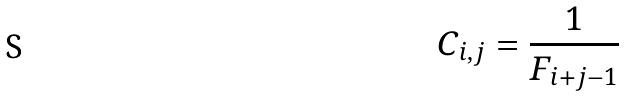Convert formula to latex. <formula><loc_0><loc_0><loc_500><loc_500>C _ { i , j } = \frac { 1 } { F _ { i + j - 1 } }</formula> 